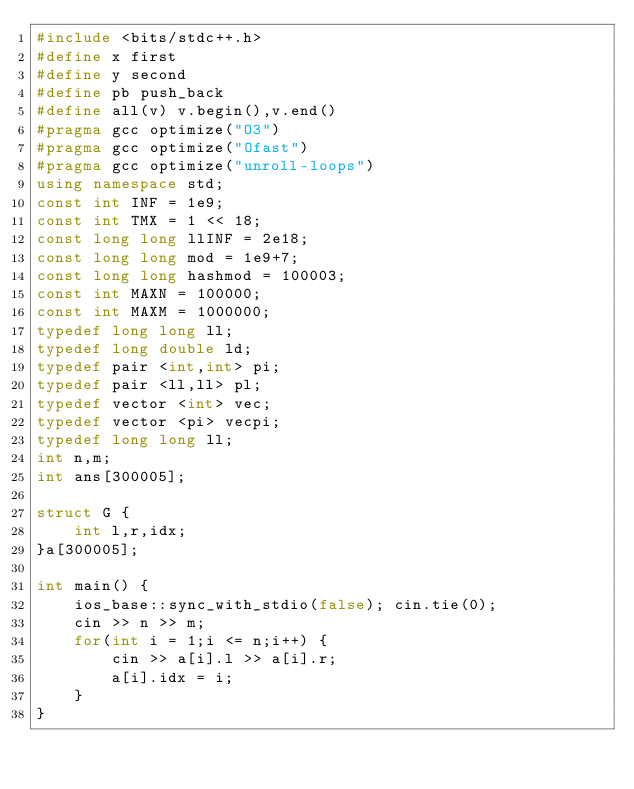<code> <loc_0><loc_0><loc_500><loc_500><_C++_>#include <bits/stdc++.h>
#define x first
#define y second
#define pb push_back
#define all(v) v.begin(),v.end()
#pragma gcc optimize("O3")
#pragma gcc optimize("Ofast") 
#pragma gcc optimize("unroll-loops")
using namespace std;
const int INF = 1e9;
const int TMX = 1 << 18;
const long long llINF = 2e18;
const long long mod = 1e9+7;
const long long hashmod = 100003;
const int MAXN = 100000;
const int MAXM = 1000000;
typedef long long ll;
typedef long double ld;
typedef pair <int,int> pi;
typedef pair <ll,ll> pl;
typedef vector <int> vec;
typedef vector <pi> vecpi;
typedef long long ll;
int n,m;
int ans[300005];

struct G {
	int l,r,idx;
}a[300005];

int main() {
	ios_base::sync_with_stdio(false); cin.tie(0);
	cin >> n >> m;
	for(int i = 1;i <= n;i++) {
		cin >> a[i].l >> a[i].r;
		a[i].idx = i;
	}
}</code> 